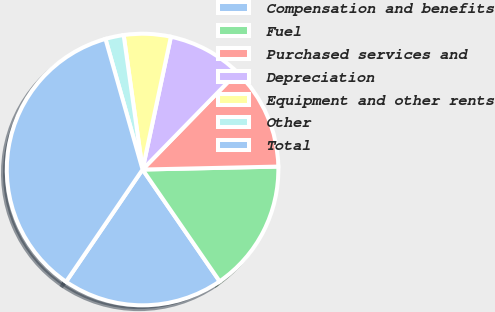<chart> <loc_0><loc_0><loc_500><loc_500><pie_chart><fcel>Compensation and benefits<fcel>Fuel<fcel>Purchased services and<fcel>Depreciation<fcel>Equipment and other rents<fcel>Other<fcel>Total<nl><fcel>19.13%<fcel>15.74%<fcel>12.35%<fcel>8.96%<fcel>5.57%<fcel>2.18%<fcel>36.07%<nl></chart> 